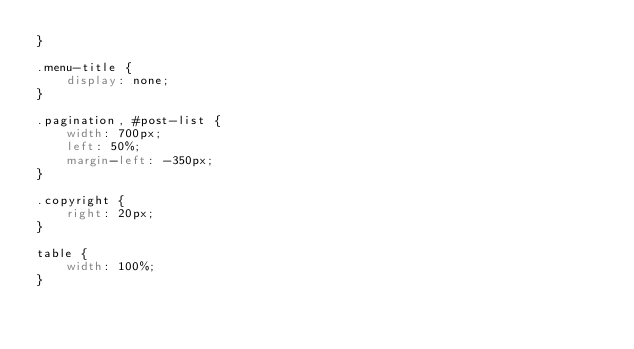<code> <loc_0><loc_0><loc_500><loc_500><_CSS_>}

.menu-title {
	display: none;
}

.pagination, #post-list {
	width: 700px;
	left: 50%;
	margin-left: -350px;
}

.copyright {
	right: 20px;
}

table {
	width: 100%;
}
</code> 